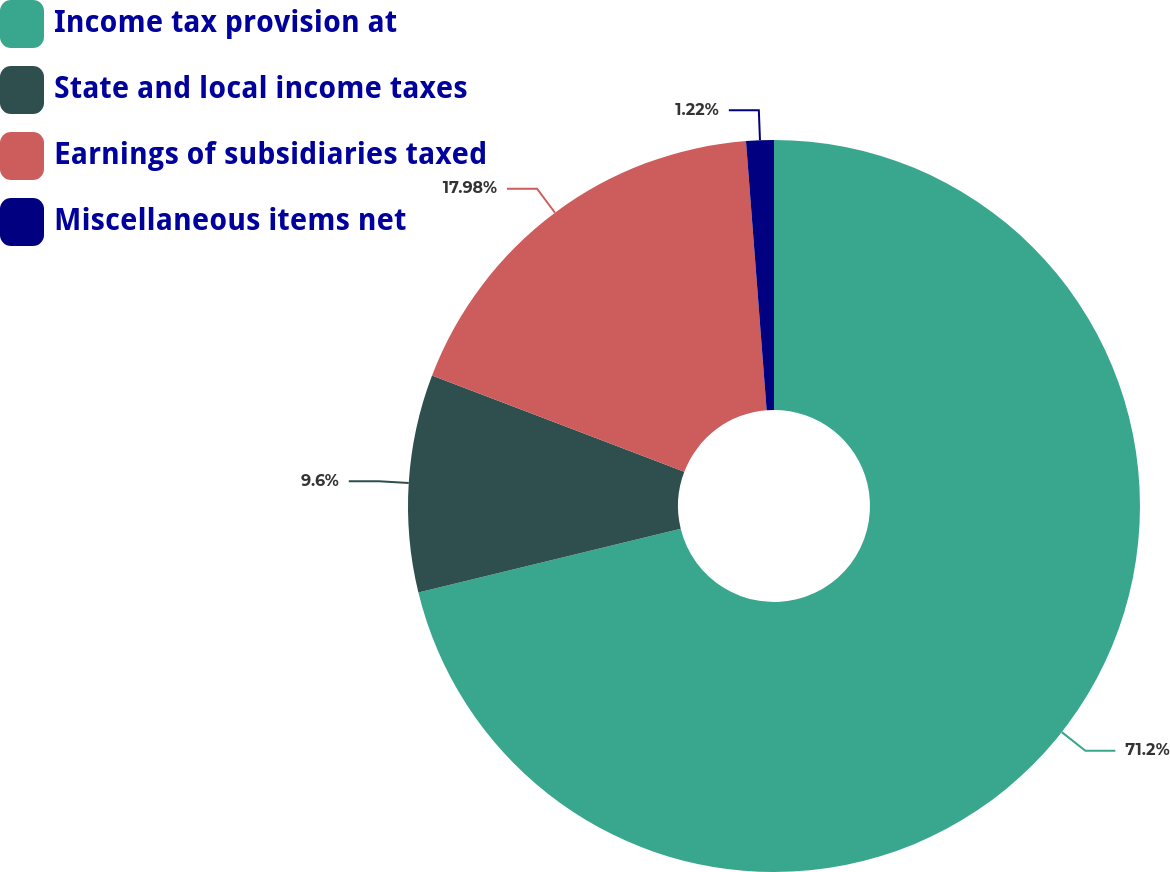Convert chart to OTSL. <chart><loc_0><loc_0><loc_500><loc_500><pie_chart><fcel>Income tax provision at<fcel>State and local income taxes<fcel>Earnings of subsidiaries taxed<fcel>Miscellaneous items net<nl><fcel>71.2%<fcel>9.6%<fcel>17.98%<fcel>1.22%<nl></chart> 